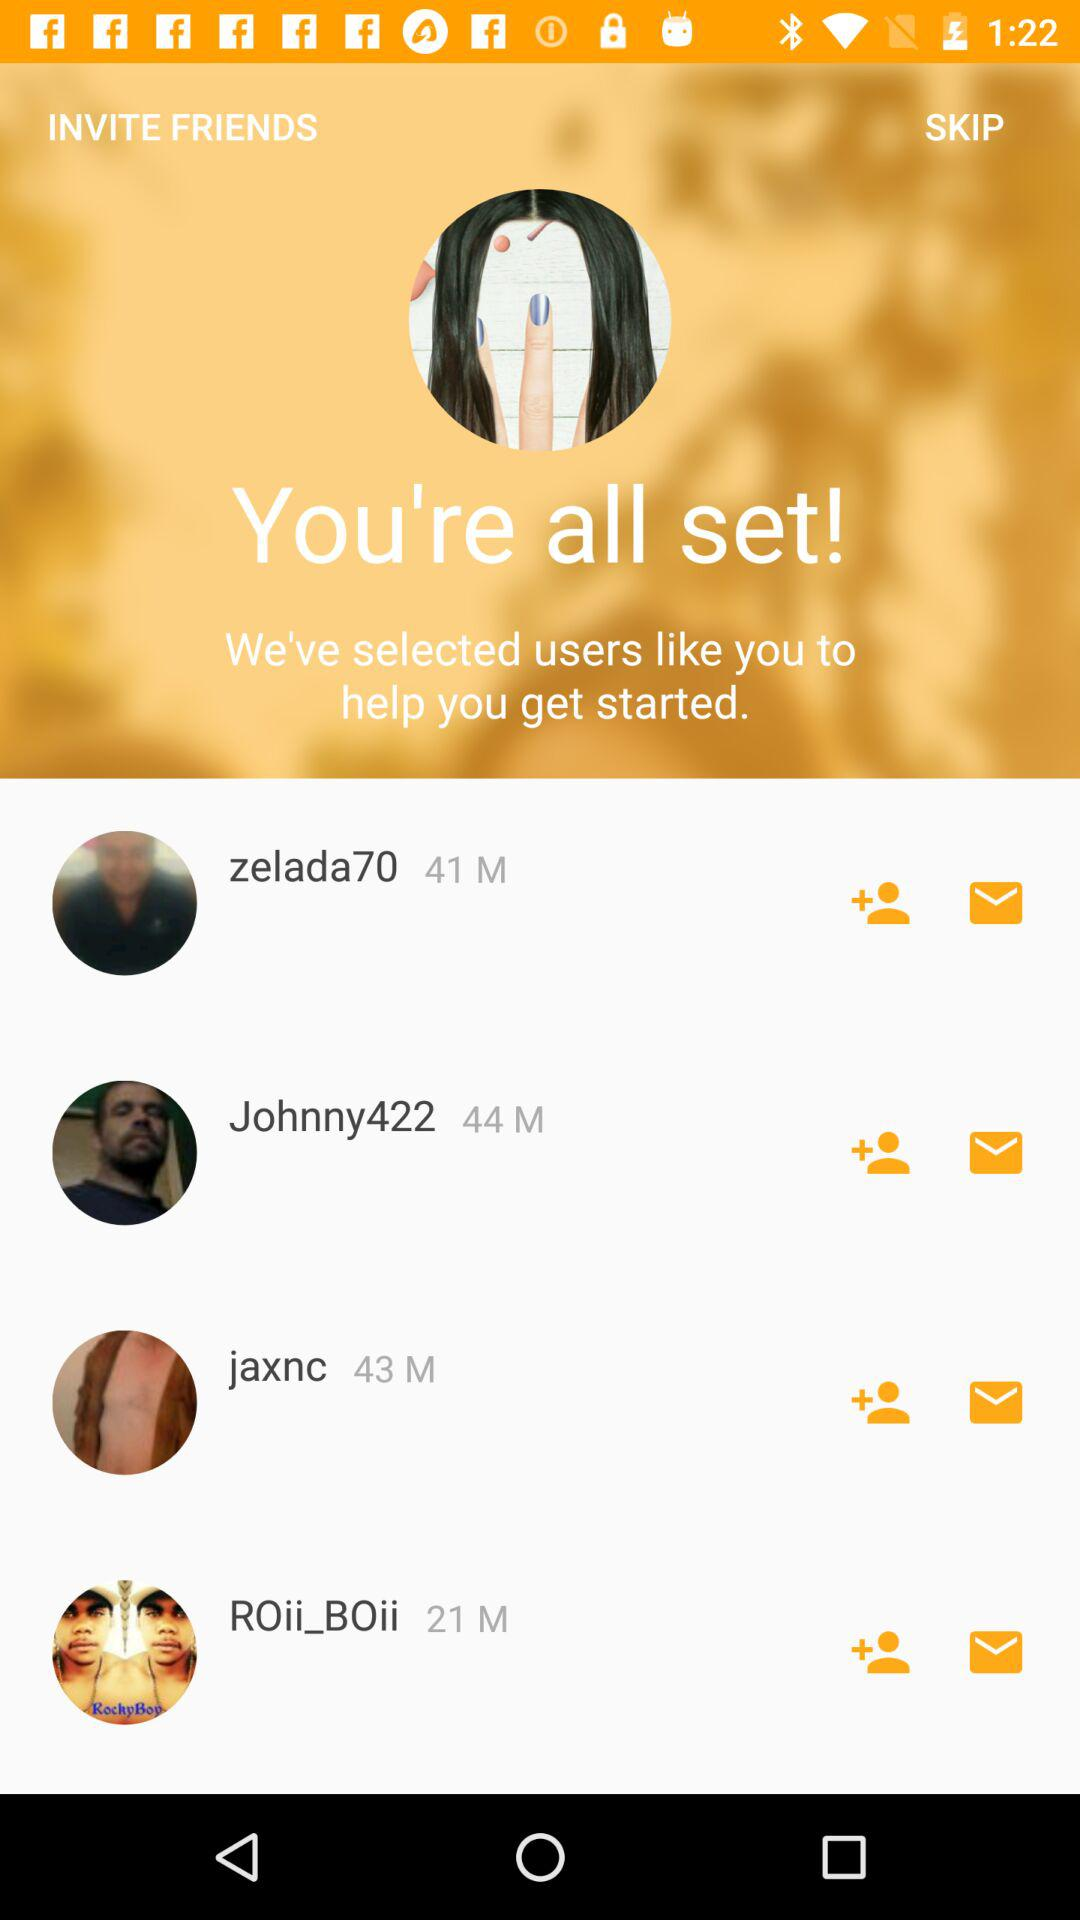What is the age of "zelada70"? The age is 41. 